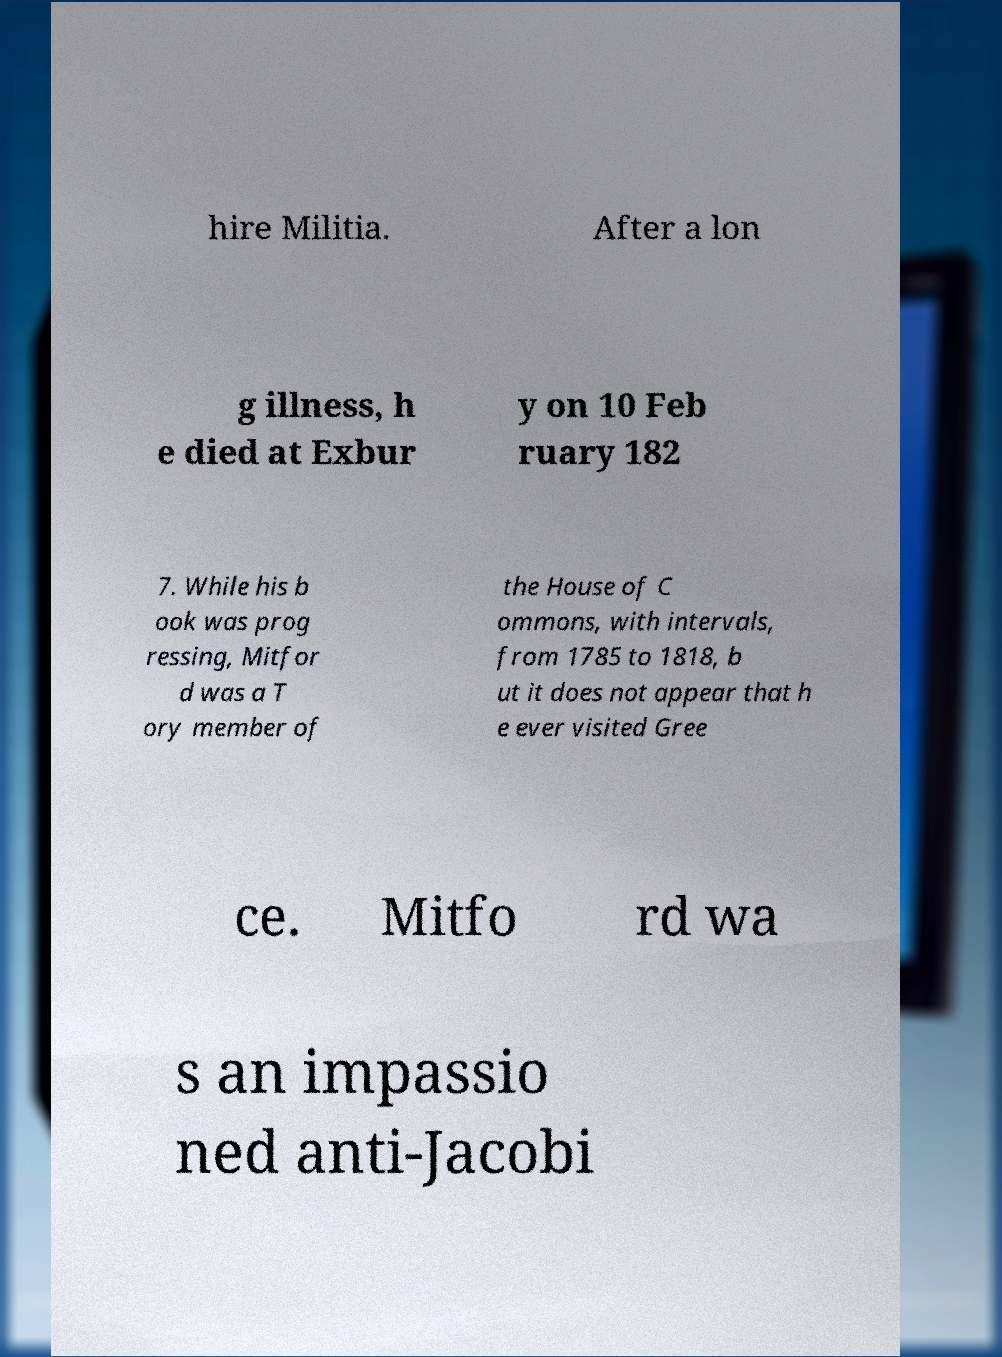Please read and relay the text visible in this image. What does it say? hire Militia. After a lon g illness, h e died at Exbur y on 10 Feb ruary 182 7. While his b ook was prog ressing, Mitfor d was a T ory member of the House of C ommons, with intervals, from 1785 to 1818, b ut it does not appear that h e ever visited Gree ce. Mitfo rd wa s an impassio ned anti-Jacobi 